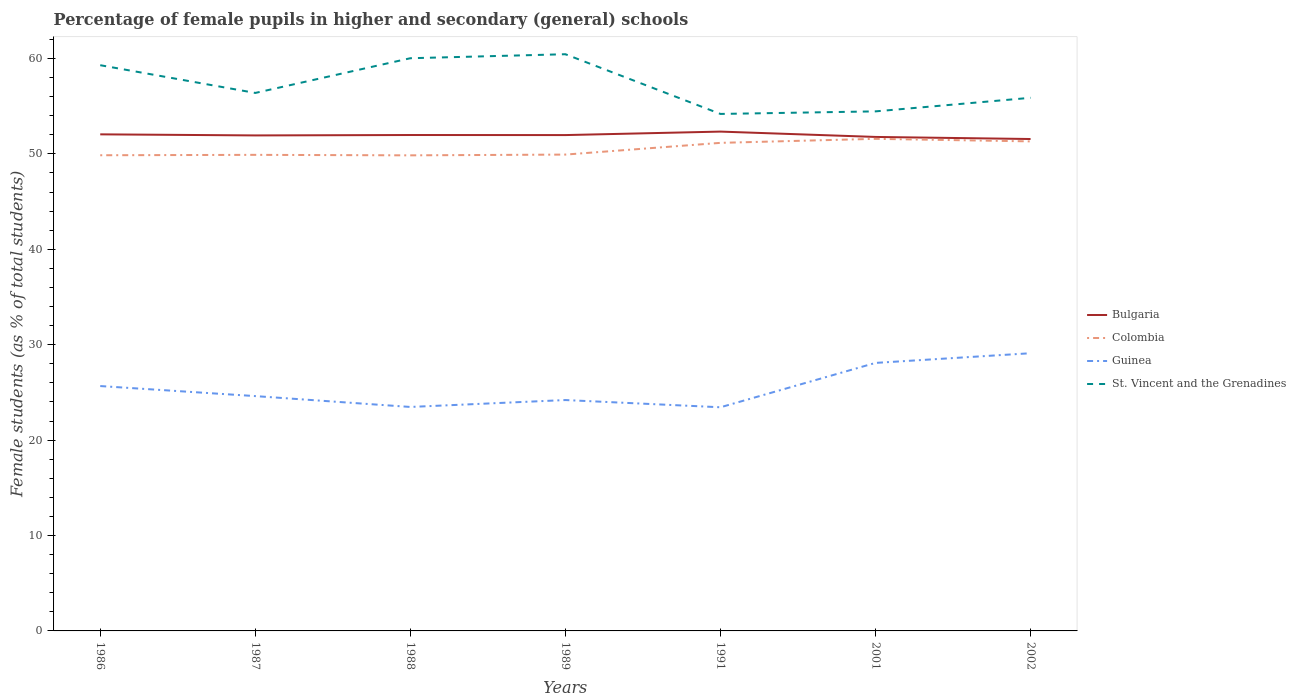Is the number of lines equal to the number of legend labels?
Your response must be concise. Yes. Across all years, what is the maximum percentage of female pupils in higher and secondary schools in St. Vincent and the Grenadines?
Your response must be concise. 54.19. What is the total percentage of female pupils in higher and secondary schools in Colombia in the graph?
Your answer should be very brief. -1.46. What is the difference between the highest and the second highest percentage of female pupils in higher and secondary schools in St. Vincent and the Grenadines?
Give a very brief answer. 6.26. How many lines are there?
Provide a short and direct response. 4. What is the difference between two consecutive major ticks on the Y-axis?
Offer a very short reply. 10. Are the values on the major ticks of Y-axis written in scientific E-notation?
Give a very brief answer. No. Where does the legend appear in the graph?
Your answer should be very brief. Center right. How many legend labels are there?
Provide a succinct answer. 4. How are the legend labels stacked?
Make the answer very short. Vertical. What is the title of the graph?
Keep it short and to the point. Percentage of female pupils in higher and secondary (general) schools. What is the label or title of the X-axis?
Provide a succinct answer. Years. What is the label or title of the Y-axis?
Your response must be concise. Female students (as % of total students). What is the Female students (as % of total students) in Bulgaria in 1986?
Your answer should be very brief. 52.05. What is the Female students (as % of total students) of Colombia in 1986?
Offer a terse response. 49.86. What is the Female students (as % of total students) in Guinea in 1986?
Provide a short and direct response. 25.67. What is the Female students (as % of total students) in St. Vincent and the Grenadines in 1986?
Provide a succinct answer. 59.3. What is the Female students (as % of total students) of Bulgaria in 1987?
Your answer should be very brief. 51.94. What is the Female students (as % of total students) of Colombia in 1987?
Ensure brevity in your answer.  49.9. What is the Female students (as % of total students) of Guinea in 1987?
Provide a succinct answer. 24.61. What is the Female students (as % of total students) of St. Vincent and the Grenadines in 1987?
Provide a short and direct response. 56.39. What is the Female students (as % of total students) in Bulgaria in 1988?
Ensure brevity in your answer.  51.98. What is the Female students (as % of total students) of Colombia in 1988?
Offer a very short reply. 49.85. What is the Female students (as % of total students) of Guinea in 1988?
Make the answer very short. 23.47. What is the Female students (as % of total students) of St. Vincent and the Grenadines in 1988?
Provide a short and direct response. 60.03. What is the Female students (as % of total students) in Bulgaria in 1989?
Make the answer very short. 51.97. What is the Female students (as % of total students) in Colombia in 1989?
Provide a short and direct response. 49.93. What is the Female students (as % of total students) in Guinea in 1989?
Offer a very short reply. 24.2. What is the Female students (as % of total students) of St. Vincent and the Grenadines in 1989?
Provide a succinct answer. 60.45. What is the Female students (as % of total students) of Bulgaria in 1991?
Your answer should be compact. 52.34. What is the Female students (as % of total students) of Colombia in 1991?
Your answer should be very brief. 51.16. What is the Female students (as % of total students) in Guinea in 1991?
Your response must be concise. 23.44. What is the Female students (as % of total students) in St. Vincent and the Grenadines in 1991?
Your answer should be compact. 54.19. What is the Female students (as % of total students) of Bulgaria in 2001?
Make the answer very short. 51.78. What is the Female students (as % of total students) in Colombia in 2001?
Give a very brief answer. 51.58. What is the Female students (as % of total students) in Guinea in 2001?
Make the answer very short. 28.09. What is the Female students (as % of total students) of St. Vincent and the Grenadines in 2001?
Offer a very short reply. 54.46. What is the Female students (as % of total students) of Bulgaria in 2002?
Your answer should be compact. 51.56. What is the Female students (as % of total students) of Colombia in 2002?
Provide a succinct answer. 51.31. What is the Female students (as % of total students) in Guinea in 2002?
Ensure brevity in your answer.  29.11. What is the Female students (as % of total students) in St. Vincent and the Grenadines in 2002?
Ensure brevity in your answer.  55.88. Across all years, what is the maximum Female students (as % of total students) in Bulgaria?
Provide a short and direct response. 52.34. Across all years, what is the maximum Female students (as % of total students) in Colombia?
Offer a terse response. 51.58. Across all years, what is the maximum Female students (as % of total students) in Guinea?
Your answer should be compact. 29.11. Across all years, what is the maximum Female students (as % of total students) in St. Vincent and the Grenadines?
Ensure brevity in your answer.  60.45. Across all years, what is the minimum Female students (as % of total students) in Bulgaria?
Your answer should be very brief. 51.56. Across all years, what is the minimum Female students (as % of total students) in Colombia?
Your response must be concise. 49.85. Across all years, what is the minimum Female students (as % of total students) of Guinea?
Your response must be concise. 23.44. Across all years, what is the minimum Female students (as % of total students) of St. Vincent and the Grenadines?
Offer a very short reply. 54.19. What is the total Female students (as % of total students) in Bulgaria in the graph?
Make the answer very short. 363.61. What is the total Female students (as % of total students) in Colombia in the graph?
Make the answer very short. 353.58. What is the total Female students (as % of total students) in Guinea in the graph?
Keep it short and to the point. 178.59. What is the total Female students (as % of total students) in St. Vincent and the Grenadines in the graph?
Keep it short and to the point. 400.68. What is the difference between the Female students (as % of total students) of Bulgaria in 1986 and that in 1987?
Provide a succinct answer. 0.11. What is the difference between the Female students (as % of total students) in Colombia in 1986 and that in 1987?
Keep it short and to the point. -0.04. What is the difference between the Female students (as % of total students) of Guinea in 1986 and that in 1987?
Provide a succinct answer. 1.05. What is the difference between the Female students (as % of total students) in St. Vincent and the Grenadines in 1986 and that in 1987?
Offer a very short reply. 2.91. What is the difference between the Female students (as % of total students) of Bulgaria in 1986 and that in 1988?
Provide a succinct answer. 0.07. What is the difference between the Female students (as % of total students) in Colombia in 1986 and that in 1988?
Keep it short and to the point. 0.01. What is the difference between the Female students (as % of total students) of Guinea in 1986 and that in 1988?
Offer a terse response. 2.19. What is the difference between the Female students (as % of total students) in St. Vincent and the Grenadines in 1986 and that in 1988?
Your answer should be very brief. -0.73. What is the difference between the Female students (as % of total students) in Bulgaria in 1986 and that in 1989?
Offer a terse response. 0.08. What is the difference between the Female students (as % of total students) in Colombia in 1986 and that in 1989?
Your answer should be very brief. -0.07. What is the difference between the Female students (as % of total students) in Guinea in 1986 and that in 1989?
Ensure brevity in your answer.  1.47. What is the difference between the Female students (as % of total students) in St. Vincent and the Grenadines in 1986 and that in 1989?
Your answer should be compact. -1.15. What is the difference between the Female students (as % of total students) in Bulgaria in 1986 and that in 1991?
Give a very brief answer. -0.29. What is the difference between the Female students (as % of total students) of Colombia in 1986 and that in 1991?
Provide a succinct answer. -1.3. What is the difference between the Female students (as % of total students) of Guinea in 1986 and that in 1991?
Offer a terse response. 2.22. What is the difference between the Female students (as % of total students) of St. Vincent and the Grenadines in 1986 and that in 1991?
Provide a succinct answer. 5.11. What is the difference between the Female students (as % of total students) of Bulgaria in 1986 and that in 2001?
Your answer should be very brief. 0.27. What is the difference between the Female students (as % of total students) in Colombia in 1986 and that in 2001?
Your response must be concise. -1.72. What is the difference between the Female students (as % of total students) in Guinea in 1986 and that in 2001?
Ensure brevity in your answer.  -2.43. What is the difference between the Female students (as % of total students) in St. Vincent and the Grenadines in 1986 and that in 2001?
Your answer should be compact. 4.84. What is the difference between the Female students (as % of total students) of Bulgaria in 1986 and that in 2002?
Keep it short and to the point. 0.49. What is the difference between the Female students (as % of total students) of Colombia in 1986 and that in 2002?
Keep it short and to the point. -1.45. What is the difference between the Female students (as % of total students) in Guinea in 1986 and that in 2002?
Offer a terse response. -3.44. What is the difference between the Female students (as % of total students) in St. Vincent and the Grenadines in 1986 and that in 2002?
Your answer should be compact. 3.42. What is the difference between the Female students (as % of total students) of Bulgaria in 1987 and that in 1988?
Offer a very short reply. -0.04. What is the difference between the Female students (as % of total students) in Colombia in 1987 and that in 1988?
Provide a short and direct response. 0.05. What is the difference between the Female students (as % of total students) of Guinea in 1987 and that in 1988?
Provide a short and direct response. 1.14. What is the difference between the Female students (as % of total students) of St. Vincent and the Grenadines in 1987 and that in 1988?
Provide a short and direct response. -3.64. What is the difference between the Female students (as % of total students) in Bulgaria in 1987 and that in 1989?
Your response must be concise. -0.04. What is the difference between the Female students (as % of total students) of Colombia in 1987 and that in 1989?
Your response must be concise. -0.03. What is the difference between the Female students (as % of total students) of Guinea in 1987 and that in 1989?
Make the answer very short. 0.41. What is the difference between the Female students (as % of total students) of St. Vincent and the Grenadines in 1987 and that in 1989?
Give a very brief answer. -4.06. What is the difference between the Female students (as % of total students) in Bulgaria in 1987 and that in 1991?
Make the answer very short. -0.4. What is the difference between the Female students (as % of total students) of Colombia in 1987 and that in 1991?
Your answer should be very brief. -1.26. What is the difference between the Female students (as % of total students) of Guinea in 1987 and that in 1991?
Provide a short and direct response. 1.17. What is the difference between the Female students (as % of total students) of St. Vincent and the Grenadines in 1987 and that in 1991?
Make the answer very short. 2.2. What is the difference between the Female students (as % of total students) of Bulgaria in 1987 and that in 2001?
Keep it short and to the point. 0.16. What is the difference between the Female students (as % of total students) of Colombia in 1987 and that in 2001?
Offer a terse response. -1.68. What is the difference between the Female students (as % of total students) of Guinea in 1987 and that in 2001?
Your answer should be compact. -3.48. What is the difference between the Female students (as % of total students) of St. Vincent and the Grenadines in 1987 and that in 2001?
Ensure brevity in your answer.  1.93. What is the difference between the Female students (as % of total students) in Bulgaria in 1987 and that in 2002?
Provide a short and direct response. 0.38. What is the difference between the Female students (as % of total students) in Colombia in 1987 and that in 2002?
Offer a very short reply. -1.41. What is the difference between the Female students (as % of total students) in Guinea in 1987 and that in 2002?
Give a very brief answer. -4.49. What is the difference between the Female students (as % of total students) of St. Vincent and the Grenadines in 1987 and that in 2002?
Give a very brief answer. 0.51. What is the difference between the Female students (as % of total students) in Bulgaria in 1988 and that in 1989?
Provide a succinct answer. 0.01. What is the difference between the Female students (as % of total students) of Colombia in 1988 and that in 1989?
Ensure brevity in your answer.  -0.08. What is the difference between the Female students (as % of total students) of Guinea in 1988 and that in 1989?
Your response must be concise. -0.72. What is the difference between the Female students (as % of total students) of St. Vincent and the Grenadines in 1988 and that in 1989?
Ensure brevity in your answer.  -0.42. What is the difference between the Female students (as % of total students) in Bulgaria in 1988 and that in 1991?
Give a very brief answer. -0.36. What is the difference between the Female students (as % of total students) in Colombia in 1988 and that in 1991?
Your answer should be compact. -1.31. What is the difference between the Female students (as % of total students) in Guinea in 1988 and that in 1991?
Keep it short and to the point. 0.03. What is the difference between the Female students (as % of total students) of St. Vincent and the Grenadines in 1988 and that in 1991?
Make the answer very short. 5.84. What is the difference between the Female students (as % of total students) in Bulgaria in 1988 and that in 2001?
Ensure brevity in your answer.  0.2. What is the difference between the Female students (as % of total students) of Colombia in 1988 and that in 2001?
Offer a very short reply. -1.73. What is the difference between the Female students (as % of total students) of Guinea in 1988 and that in 2001?
Make the answer very short. -4.62. What is the difference between the Female students (as % of total students) of St. Vincent and the Grenadines in 1988 and that in 2001?
Ensure brevity in your answer.  5.57. What is the difference between the Female students (as % of total students) in Bulgaria in 1988 and that in 2002?
Your answer should be very brief. 0.42. What is the difference between the Female students (as % of total students) in Colombia in 1988 and that in 2002?
Make the answer very short. -1.46. What is the difference between the Female students (as % of total students) of Guinea in 1988 and that in 2002?
Keep it short and to the point. -5.63. What is the difference between the Female students (as % of total students) of St. Vincent and the Grenadines in 1988 and that in 2002?
Provide a short and direct response. 4.15. What is the difference between the Female students (as % of total students) of Bulgaria in 1989 and that in 1991?
Your answer should be very brief. -0.36. What is the difference between the Female students (as % of total students) in Colombia in 1989 and that in 1991?
Make the answer very short. -1.23. What is the difference between the Female students (as % of total students) in Guinea in 1989 and that in 1991?
Your answer should be compact. 0.76. What is the difference between the Female students (as % of total students) in St. Vincent and the Grenadines in 1989 and that in 1991?
Offer a terse response. 6.26. What is the difference between the Female students (as % of total students) in Bulgaria in 1989 and that in 2001?
Offer a terse response. 0.2. What is the difference between the Female students (as % of total students) in Colombia in 1989 and that in 2001?
Make the answer very short. -1.65. What is the difference between the Female students (as % of total students) of Guinea in 1989 and that in 2001?
Your answer should be very brief. -3.89. What is the difference between the Female students (as % of total students) in St. Vincent and the Grenadines in 1989 and that in 2001?
Keep it short and to the point. 5.99. What is the difference between the Female students (as % of total students) of Bulgaria in 1989 and that in 2002?
Provide a succinct answer. 0.41. What is the difference between the Female students (as % of total students) in Colombia in 1989 and that in 2002?
Your answer should be very brief. -1.38. What is the difference between the Female students (as % of total students) of Guinea in 1989 and that in 2002?
Ensure brevity in your answer.  -4.91. What is the difference between the Female students (as % of total students) of St. Vincent and the Grenadines in 1989 and that in 2002?
Offer a terse response. 4.57. What is the difference between the Female students (as % of total students) of Bulgaria in 1991 and that in 2001?
Offer a terse response. 0.56. What is the difference between the Female students (as % of total students) in Colombia in 1991 and that in 2001?
Make the answer very short. -0.42. What is the difference between the Female students (as % of total students) of Guinea in 1991 and that in 2001?
Give a very brief answer. -4.65. What is the difference between the Female students (as % of total students) of St. Vincent and the Grenadines in 1991 and that in 2001?
Your response must be concise. -0.27. What is the difference between the Female students (as % of total students) of Bulgaria in 1991 and that in 2002?
Provide a succinct answer. 0.78. What is the difference between the Female students (as % of total students) in Colombia in 1991 and that in 2002?
Your answer should be very brief. -0.15. What is the difference between the Female students (as % of total students) in Guinea in 1991 and that in 2002?
Provide a succinct answer. -5.67. What is the difference between the Female students (as % of total students) of St. Vincent and the Grenadines in 1991 and that in 2002?
Your answer should be very brief. -1.69. What is the difference between the Female students (as % of total students) of Bulgaria in 2001 and that in 2002?
Your answer should be compact. 0.22. What is the difference between the Female students (as % of total students) of Colombia in 2001 and that in 2002?
Keep it short and to the point. 0.27. What is the difference between the Female students (as % of total students) in Guinea in 2001 and that in 2002?
Your answer should be very brief. -1.01. What is the difference between the Female students (as % of total students) of St. Vincent and the Grenadines in 2001 and that in 2002?
Provide a short and direct response. -1.42. What is the difference between the Female students (as % of total students) of Bulgaria in 1986 and the Female students (as % of total students) of Colombia in 1987?
Offer a very short reply. 2.15. What is the difference between the Female students (as % of total students) in Bulgaria in 1986 and the Female students (as % of total students) in Guinea in 1987?
Ensure brevity in your answer.  27.44. What is the difference between the Female students (as % of total students) in Bulgaria in 1986 and the Female students (as % of total students) in St. Vincent and the Grenadines in 1987?
Provide a succinct answer. -4.34. What is the difference between the Female students (as % of total students) of Colombia in 1986 and the Female students (as % of total students) of Guinea in 1987?
Provide a short and direct response. 25.24. What is the difference between the Female students (as % of total students) of Colombia in 1986 and the Female students (as % of total students) of St. Vincent and the Grenadines in 1987?
Your answer should be compact. -6.53. What is the difference between the Female students (as % of total students) in Guinea in 1986 and the Female students (as % of total students) in St. Vincent and the Grenadines in 1987?
Your answer should be very brief. -30.72. What is the difference between the Female students (as % of total students) of Bulgaria in 1986 and the Female students (as % of total students) of Colombia in 1988?
Your answer should be compact. 2.2. What is the difference between the Female students (as % of total students) in Bulgaria in 1986 and the Female students (as % of total students) in Guinea in 1988?
Ensure brevity in your answer.  28.57. What is the difference between the Female students (as % of total students) of Bulgaria in 1986 and the Female students (as % of total students) of St. Vincent and the Grenadines in 1988?
Keep it short and to the point. -7.98. What is the difference between the Female students (as % of total students) of Colombia in 1986 and the Female students (as % of total students) of Guinea in 1988?
Offer a very short reply. 26.38. What is the difference between the Female students (as % of total students) in Colombia in 1986 and the Female students (as % of total students) in St. Vincent and the Grenadines in 1988?
Your answer should be compact. -10.17. What is the difference between the Female students (as % of total students) in Guinea in 1986 and the Female students (as % of total students) in St. Vincent and the Grenadines in 1988?
Your answer should be compact. -34.36. What is the difference between the Female students (as % of total students) in Bulgaria in 1986 and the Female students (as % of total students) in Colombia in 1989?
Make the answer very short. 2.12. What is the difference between the Female students (as % of total students) of Bulgaria in 1986 and the Female students (as % of total students) of Guinea in 1989?
Offer a very short reply. 27.85. What is the difference between the Female students (as % of total students) of Bulgaria in 1986 and the Female students (as % of total students) of St. Vincent and the Grenadines in 1989?
Your response must be concise. -8.4. What is the difference between the Female students (as % of total students) of Colombia in 1986 and the Female students (as % of total students) of Guinea in 1989?
Keep it short and to the point. 25.66. What is the difference between the Female students (as % of total students) of Colombia in 1986 and the Female students (as % of total students) of St. Vincent and the Grenadines in 1989?
Offer a very short reply. -10.59. What is the difference between the Female students (as % of total students) of Guinea in 1986 and the Female students (as % of total students) of St. Vincent and the Grenadines in 1989?
Give a very brief answer. -34.78. What is the difference between the Female students (as % of total students) of Bulgaria in 1986 and the Female students (as % of total students) of Colombia in 1991?
Provide a short and direct response. 0.89. What is the difference between the Female students (as % of total students) in Bulgaria in 1986 and the Female students (as % of total students) in Guinea in 1991?
Your answer should be very brief. 28.61. What is the difference between the Female students (as % of total students) of Bulgaria in 1986 and the Female students (as % of total students) of St. Vincent and the Grenadines in 1991?
Make the answer very short. -2.14. What is the difference between the Female students (as % of total students) of Colombia in 1986 and the Female students (as % of total students) of Guinea in 1991?
Offer a terse response. 26.42. What is the difference between the Female students (as % of total students) of Colombia in 1986 and the Female students (as % of total students) of St. Vincent and the Grenadines in 1991?
Give a very brief answer. -4.33. What is the difference between the Female students (as % of total students) in Guinea in 1986 and the Female students (as % of total students) in St. Vincent and the Grenadines in 1991?
Keep it short and to the point. -28.52. What is the difference between the Female students (as % of total students) in Bulgaria in 1986 and the Female students (as % of total students) in Colombia in 2001?
Make the answer very short. 0.47. What is the difference between the Female students (as % of total students) in Bulgaria in 1986 and the Female students (as % of total students) in Guinea in 2001?
Your answer should be compact. 23.96. What is the difference between the Female students (as % of total students) of Bulgaria in 1986 and the Female students (as % of total students) of St. Vincent and the Grenadines in 2001?
Your response must be concise. -2.41. What is the difference between the Female students (as % of total students) of Colombia in 1986 and the Female students (as % of total students) of Guinea in 2001?
Your answer should be compact. 21.76. What is the difference between the Female students (as % of total students) of Colombia in 1986 and the Female students (as % of total students) of St. Vincent and the Grenadines in 2001?
Offer a very short reply. -4.6. What is the difference between the Female students (as % of total students) of Guinea in 1986 and the Female students (as % of total students) of St. Vincent and the Grenadines in 2001?
Keep it short and to the point. -28.79. What is the difference between the Female students (as % of total students) of Bulgaria in 1986 and the Female students (as % of total students) of Colombia in 2002?
Ensure brevity in your answer.  0.74. What is the difference between the Female students (as % of total students) in Bulgaria in 1986 and the Female students (as % of total students) in Guinea in 2002?
Keep it short and to the point. 22.94. What is the difference between the Female students (as % of total students) in Bulgaria in 1986 and the Female students (as % of total students) in St. Vincent and the Grenadines in 2002?
Ensure brevity in your answer.  -3.83. What is the difference between the Female students (as % of total students) of Colombia in 1986 and the Female students (as % of total students) of Guinea in 2002?
Provide a succinct answer. 20.75. What is the difference between the Female students (as % of total students) of Colombia in 1986 and the Female students (as % of total students) of St. Vincent and the Grenadines in 2002?
Make the answer very short. -6.02. What is the difference between the Female students (as % of total students) of Guinea in 1986 and the Female students (as % of total students) of St. Vincent and the Grenadines in 2002?
Provide a short and direct response. -30.21. What is the difference between the Female students (as % of total students) of Bulgaria in 1987 and the Female students (as % of total students) of Colombia in 1988?
Your response must be concise. 2.09. What is the difference between the Female students (as % of total students) of Bulgaria in 1987 and the Female students (as % of total students) of Guinea in 1988?
Give a very brief answer. 28.46. What is the difference between the Female students (as % of total students) of Bulgaria in 1987 and the Female students (as % of total students) of St. Vincent and the Grenadines in 1988?
Offer a very short reply. -8.09. What is the difference between the Female students (as % of total students) of Colombia in 1987 and the Female students (as % of total students) of Guinea in 1988?
Offer a terse response. 26.42. What is the difference between the Female students (as % of total students) of Colombia in 1987 and the Female students (as % of total students) of St. Vincent and the Grenadines in 1988?
Provide a short and direct response. -10.13. What is the difference between the Female students (as % of total students) of Guinea in 1987 and the Female students (as % of total students) of St. Vincent and the Grenadines in 1988?
Your response must be concise. -35.41. What is the difference between the Female students (as % of total students) in Bulgaria in 1987 and the Female students (as % of total students) in Colombia in 1989?
Make the answer very short. 2.01. What is the difference between the Female students (as % of total students) in Bulgaria in 1987 and the Female students (as % of total students) in Guinea in 1989?
Provide a succinct answer. 27.74. What is the difference between the Female students (as % of total students) of Bulgaria in 1987 and the Female students (as % of total students) of St. Vincent and the Grenadines in 1989?
Offer a terse response. -8.51. What is the difference between the Female students (as % of total students) of Colombia in 1987 and the Female students (as % of total students) of Guinea in 1989?
Make the answer very short. 25.7. What is the difference between the Female students (as % of total students) in Colombia in 1987 and the Female students (as % of total students) in St. Vincent and the Grenadines in 1989?
Provide a succinct answer. -10.55. What is the difference between the Female students (as % of total students) in Guinea in 1987 and the Female students (as % of total students) in St. Vincent and the Grenadines in 1989?
Make the answer very short. -35.83. What is the difference between the Female students (as % of total students) in Bulgaria in 1987 and the Female students (as % of total students) in Colombia in 1991?
Offer a very short reply. 0.78. What is the difference between the Female students (as % of total students) of Bulgaria in 1987 and the Female students (as % of total students) of Guinea in 1991?
Give a very brief answer. 28.49. What is the difference between the Female students (as % of total students) in Bulgaria in 1987 and the Female students (as % of total students) in St. Vincent and the Grenadines in 1991?
Make the answer very short. -2.25. What is the difference between the Female students (as % of total students) in Colombia in 1987 and the Female students (as % of total students) in Guinea in 1991?
Keep it short and to the point. 26.46. What is the difference between the Female students (as % of total students) of Colombia in 1987 and the Female students (as % of total students) of St. Vincent and the Grenadines in 1991?
Make the answer very short. -4.29. What is the difference between the Female students (as % of total students) in Guinea in 1987 and the Female students (as % of total students) in St. Vincent and the Grenadines in 1991?
Your answer should be very brief. -29.57. What is the difference between the Female students (as % of total students) of Bulgaria in 1987 and the Female students (as % of total students) of Colombia in 2001?
Your answer should be very brief. 0.36. What is the difference between the Female students (as % of total students) of Bulgaria in 1987 and the Female students (as % of total students) of Guinea in 2001?
Give a very brief answer. 23.84. What is the difference between the Female students (as % of total students) of Bulgaria in 1987 and the Female students (as % of total students) of St. Vincent and the Grenadines in 2001?
Provide a succinct answer. -2.52. What is the difference between the Female students (as % of total students) in Colombia in 1987 and the Female students (as % of total students) in Guinea in 2001?
Ensure brevity in your answer.  21.81. What is the difference between the Female students (as % of total students) of Colombia in 1987 and the Female students (as % of total students) of St. Vincent and the Grenadines in 2001?
Provide a short and direct response. -4.56. What is the difference between the Female students (as % of total students) of Guinea in 1987 and the Female students (as % of total students) of St. Vincent and the Grenadines in 2001?
Give a very brief answer. -29.84. What is the difference between the Female students (as % of total students) of Bulgaria in 1987 and the Female students (as % of total students) of Colombia in 2002?
Ensure brevity in your answer.  0.63. What is the difference between the Female students (as % of total students) in Bulgaria in 1987 and the Female students (as % of total students) in Guinea in 2002?
Offer a terse response. 22.83. What is the difference between the Female students (as % of total students) in Bulgaria in 1987 and the Female students (as % of total students) in St. Vincent and the Grenadines in 2002?
Your response must be concise. -3.94. What is the difference between the Female students (as % of total students) of Colombia in 1987 and the Female students (as % of total students) of Guinea in 2002?
Ensure brevity in your answer.  20.79. What is the difference between the Female students (as % of total students) of Colombia in 1987 and the Female students (as % of total students) of St. Vincent and the Grenadines in 2002?
Ensure brevity in your answer.  -5.98. What is the difference between the Female students (as % of total students) of Guinea in 1987 and the Female students (as % of total students) of St. Vincent and the Grenadines in 2002?
Keep it short and to the point. -31.27. What is the difference between the Female students (as % of total students) in Bulgaria in 1988 and the Female students (as % of total students) in Colombia in 1989?
Your answer should be very brief. 2.05. What is the difference between the Female students (as % of total students) of Bulgaria in 1988 and the Female students (as % of total students) of Guinea in 1989?
Your answer should be very brief. 27.78. What is the difference between the Female students (as % of total students) in Bulgaria in 1988 and the Female students (as % of total students) in St. Vincent and the Grenadines in 1989?
Make the answer very short. -8.47. What is the difference between the Female students (as % of total students) of Colombia in 1988 and the Female students (as % of total students) of Guinea in 1989?
Offer a terse response. 25.65. What is the difference between the Female students (as % of total students) of Colombia in 1988 and the Female students (as % of total students) of St. Vincent and the Grenadines in 1989?
Your answer should be very brief. -10.6. What is the difference between the Female students (as % of total students) in Guinea in 1988 and the Female students (as % of total students) in St. Vincent and the Grenadines in 1989?
Offer a very short reply. -36.97. What is the difference between the Female students (as % of total students) in Bulgaria in 1988 and the Female students (as % of total students) in Colombia in 1991?
Provide a succinct answer. 0.82. What is the difference between the Female students (as % of total students) of Bulgaria in 1988 and the Female students (as % of total students) of Guinea in 1991?
Ensure brevity in your answer.  28.54. What is the difference between the Female students (as % of total students) of Bulgaria in 1988 and the Female students (as % of total students) of St. Vincent and the Grenadines in 1991?
Your answer should be very brief. -2.21. What is the difference between the Female students (as % of total students) of Colombia in 1988 and the Female students (as % of total students) of Guinea in 1991?
Offer a terse response. 26.41. What is the difference between the Female students (as % of total students) of Colombia in 1988 and the Female students (as % of total students) of St. Vincent and the Grenadines in 1991?
Ensure brevity in your answer.  -4.34. What is the difference between the Female students (as % of total students) in Guinea in 1988 and the Female students (as % of total students) in St. Vincent and the Grenadines in 1991?
Your response must be concise. -30.71. What is the difference between the Female students (as % of total students) in Bulgaria in 1988 and the Female students (as % of total students) in Colombia in 2001?
Your response must be concise. 0.4. What is the difference between the Female students (as % of total students) of Bulgaria in 1988 and the Female students (as % of total students) of Guinea in 2001?
Keep it short and to the point. 23.89. What is the difference between the Female students (as % of total students) of Bulgaria in 1988 and the Female students (as % of total students) of St. Vincent and the Grenadines in 2001?
Make the answer very short. -2.48. What is the difference between the Female students (as % of total students) of Colombia in 1988 and the Female students (as % of total students) of Guinea in 2001?
Your answer should be compact. 21.76. What is the difference between the Female students (as % of total students) of Colombia in 1988 and the Female students (as % of total students) of St. Vincent and the Grenadines in 2001?
Give a very brief answer. -4.61. What is the difference between the Female students (as % of total students) in Guinea in 1988 and the Female students (as % of total students) in St. Vincent and the Grenadines in 2001?
Your response must be concise. -30.98. What is the difference between the Female students (as % of total students) in Bulgaria in 1988 and the Female students (as % of total students) in Colombia in 2002?
Your answer should be very brief. 0.67. What is the difference between the Female students (as % of total students) in Bulgaria in 1988 and the Female students (as % of total students) in Guinea in 2002?
Your answer should be very brief. 22.87. What is the difference between the Female students (as % of total students) in Colombia in 1988 and the Female students (as % of total students) in Guinea in 2002?
Your response must be concise. 20.74. What is the difference between the Female students (as % of total students) in Colombia in 1988 and the Female students (as % of total students) in St. Vincent and the Grenadines in 2002?
Provide a short and direct response. -6.03. What is the difference between the Female students (as % of total students) of Guinea in 1988 and the Female students (as % of total students) of St. Vincent and the Grenadines in 2002?
Offer a terse response. -32.4. What is the difference between the Female students (as % of total students) of Bulgaria in 1989 and the Female students (as % of total students) of Colombia in 1991?
Keep it short and to the point. 0.82. What is the difference between the Female students (as % of total students) in Bulgaria in 1989 and the Female students (as % of total students) in Guinea in 1991?
Ensure brevity in your answer.  28.53. What is the difference between the Female students (as % of total students) of Bulgaria in 1989 and the Female students (as % of total students) of St. Vincent and the Grenadines in 1991?
Provide a succinct answer. -2.21. What is the difference between the Female students (as % of total students) in Colombia in 1989 and the Female students (as % of total students) in Guinea in 1991?
Provide a succinct answer. 26.49. What is the difference between the Female students (as % of total students) in Colombia in 1989 and the Female students (as % of total students) in St. Vincent and the Grenadines in 1991?
Provide a short and direct response. -4.26. What is the difference between the Female students (as % of total students) of Guinea in 1989 and the Female students (as % of total students) of St. Vincent and the Grenadines in 1991?
Offer a terse response. -29.99. What is the difference between the Female students (as % of total students) in Bulgaria in 1989 and the Female students (as % of total students) in Colombia in 2001?
Offer a terse response. 0.39. What is the difference between the Female students (as % of total students) of Bulgaria in 1989 and the Female students (as % of total students) of Guinea in 2001?
Keep it short and to the point. 23.88. What is the difference between the Female students (as % of total students) of Bulgaria in 1989 and the Female students (as % of total students) of St. Vincent and the Grenadines in 2001?
Provide a short and direct response. -2.48. What is the difference between the Female students (as % of total students) of Colombia in 1989 and the Female students (as % of total students) of Guinea in 2001?
Your answer should be compact. 21.83. What is the difference between the Female students (as % of total students) in Colombia in 1989 and the Female students (as % of total students) in St. Vincent and the Grenadines in 2001?
Provide a succinct answer. -4.53. What is the difference between the Female students (as % of total students) of Guinea in 1989 and the Female students (as % of total students) of St. Vincent and the Grenadines in 2001?
Provide a short and direct response. -30.26. What is the difference between the Female students (as % of total students) in Bulgaria in 1989 and the Female students (as % of total students) in Colombia in 2002?
Your response must be concise. 0.66. What is the difference between the Female students (as % of total students) of Bulgaria in 1989 and the Female students (as % of total students) of Guinea in 2002?
Offer a terse response. 22.87. What is the difference between the Female students (as % of total students) of Bulgaria in 1989 and the Female students (as % of total students) of St. Vincent and the Grenadines in 2002?
Offer a terse response. -3.91. What is the difference between the Female students (as % of total students) in Colombia in 1989 and the Female students (as % of total students) in Guinea in 2002?
Your answer should be very brief. 20.82. What is the difference between the Female students (as % of total students) of Colombia in 1989 and the Female students (as % of total students) of St. Vincent and the Grenadines in 2002?
Offer a terse response. -5.95. What is the difference between the Female students (as % of total students) in Guinea in 1989 and the Female students (as % of total students) in St. Vincent and the Grenadines in 2002?
Give a very brief answer. -31.68. What is the difference between the Female students (as % of total students) of Bulgaria in 1991 and the Female students (as % of total students) of Colombia in 2001?
Make the answer very short. 0.76. What is the difference between the Female students (as % of total students) in Bulgaria in 1991 and the Female students (as % of total students) in Guinea in 2001?
Your answer should be compact. 24.24. What is the difference between the Female students (as % of total students) of Bulgaria in 1991 and the Female students (as % of total students) of St. Vincent and the Grenadines in 2001?
Your answer should be compact. -2.12. What is the difference between the Female students (as % of total students) in Colombia in 1991 and the Female students (as % of total students) in Guinea in 2001?
Offer a terse response. 23.06. What is the difference between the Female students (as % of total students) in Colombia in 1991 and the Female students (as % of total students) in St. Vincent and the Grenadines in 2001?
Your answer should be compact. -3.3. What is the difference between the Female students (as % of total students) of Guinea in 1991 and the Female students (as % of total students) of St. Vincent and the Grenadines in 2001?
Your answer should be compact. -31.01. What is the difference between the Female students (as % of total students) in Bulgaria in 1991 and the Female students (as % of total students) in Colombia in 2002?
Keep it short and to the point. 1.03. What is the difference between the Female students (as % of total students) in Bulgaria in 1991 and the Female students (as % of total students) in Guinea in 2002?
Give a very brief answer. 23.23. What is the difference between the Female students (as % of total students) of Bulgaria in 1991 and the Female students (as % of total students) of St. Vincent and the Grenadines in 2002?
Provide a succinct answer. -3.54. What is the difference between the Female students (as % of total students) in Colombia in 1991 and the Female students (as % of total students) in Guinea in 2002?
Your answer should be compact. 22.05. What is the difference between the Female students (as % of total students) in Colombia in 1991 and the Female students (as % of total students) in St. Vincent and the Grenadines in 2002?
Offer a very short reply. -4.72. What is the difference between the Female students (as % of total students) in Guinea in 1991 and the Female students (as % of total students) in St. Vincent and the Grenadines in 2002?
Keep it short and to the point. -32.44. What is the difference between the Female students (as % of total students) of Bulgaria in 2001 and the Female students (as % of total students) of Colombia in 2002?
Offer a terse response. 0.47. What is the difference between the Female students (as % of total students) in Bulgaria in 2001 and the Female students (as % of total students) in Guinea in 2002?
Give a very brief answer. 22.67. What is the difference between the Female students (as % of total students) of Bulgaria in 2001 and the Female students (as % of total students) of St. Vincent and the Grenadines in 2002?
Ensure brevity in your answer.  -4.1. What is the difference between the Female students (as % of total students) in Colombia in 2001 and the Female students (as % of total students) in Guinea in 2002?
Your answer should be compact. 22.47. What is the difference between the Female students (as % of total students) in Colombia in 2001 and the Female students (as % of total students) in St. Vincent and the Grenadines in 2002?
Make the answer very short. -4.3. What is the difference between the Female students (as % of total students) in Guinea in 2001 and the Female students (as % of total students) in St. Vincent and the Grenadines in 2002?
Offer a terse response. -27.79. What is the average Female students (as % of total students) in Bulgaria per year?
Offer a very short reply. 51.94. What is the average Female students (as % of total students) in Colombia per year?
Ensure brevity in your answer.  50.51. What is the average Female students (as % of total students) in Guinea per year?
Ensure brevity in your answer.  25.51. What is the average Female students (as % of total students) of St. Vincent and the Grenadines per year?
Provide a succinct answer. 57.24. In the year 1986, what is the difference between the Female students (as % of total students) of Bulgaria and Female students (as % of total students) of Colombia?
Provide a short and direct response. 2.19. In the year 1986, what is the difference between the Female students (as % of total students) in Bulgaria and Female students (as % of total students) in Guinea?
Provide a succinct answer. 26.38. In the year 1986, what is the difference between the Female students (as % of total students) of Bulgaria and Female students (as % of total students) of St. Vincent and the Grenadines?
Give a very brief answer. -7.25. In the year 1986, what is the difference between the Female students (as % of total students) of Colombia and Female students (as % of total students) of Guinea?
Offer a very short reply. 24.19. In the year 1986, what is the difference between the Female students (as % of total students) of Colombia and Female students (as % of total students) of St. Vincent and the Grenadines?
Provide a short and direct response. -9.44. In the year 1986, what is the difference between the Female students (as % of total students) in Guinea and Female students (as % of total students) in St. Vincent and the Grenadines?
Provide a succinct answer. -33.63. In the year 1987, what is the difference between the Female students (as % of total students) of Bulgaria and Female students (as % of total students) of Colombia?
Your answer should be very brief. 2.04. In the year 1987, what is the difference between the Female students (as % of total students) of Bulgaria and Female students (as % of total students) of Guinea?
Offer a terse response. 27.32. In the year 1987, what is the difference between the Female students (as % of total students) in Bulgaria and Female students (as % of total students) in St. Vincent and the Grenadines?
Offer a very short reply. -4.45. In the year 1987, what is the difference between the Female students (as % of total students) of Colombia and Female students (as % of total students) of Guinea?
Provide a succinct answer. 25.29. In the year 1987, what is the difference between the Female students (as % of total students) of Colombia and Female students (as % of total students) of St. Vincent and the Grenadines?
Your answer should be very brief. -6.49. In the year 1987, what is the difference between the Female students (as % of total students) in Guinea and Female students (as % of total students) in St. Vincent and the Grenadines?
Your answer should be compact. -31.78. In the year 1988, what is the difference between the Female students (as % of total students) of Bulgaria and Female students (as % of total students) of Colombia?
Your response must be concise. 2.13. In the year 1988, what is the difference between the Female students (as % of total students) in Bulgaria and Female students (as % of total students) in Guinea?
Make the answer very short. 28.5. In the year 1988, what is the difference between the Female students (as % of total students) in Bulgaria and Female students (as % of total students) in St. Vincent and the Grenadines?
Provide a short and direct response. -8.05. In the year 1988, what is the difference between the Female students (as % of total students) in Colombia and Female students (as % of total students) in Guinea?
Offer a very short reply. 26.37. In the year 1988, what is the difference between the Female students (as % of total students) in Colombia and Female students (as % of total students) in St. Vincent and the Grenadines?
Ensure brevity in your answer.  -10.18. In the year 1988, what is the difference between the Female students (as % of total students) in Guinea and Female students (as % of total students) in St. Vincent and the Grenadines?
Keep it short and to the point. -36.55. In the year 1989, what is the difference between the Female students (as % of total students) in Bulgaria and Female students (as % of total students) in Colombia?
Your answer should be compact. 2.04. In the year 1989, what is the difference between the Female students (as % of total students) of Bulgaria and Female students (as % of total students) of Guinea?
Your answer should be very brief. 27.77. In the year 1989, what is the difference between the Female students (as % of total students) of Bulgaria and Female students (as % of total students) of St. Vincent and the Grenadines?
Provide a short and direct response. -8.47. In the year 1989, what is the difference between the Female students (as % of total students) in Colombia and Female students (as % of total students) in Guinea?
Provide a succinct answer. 25.73. In the year 1989, what is the difference between the Female students (as % of total students) in Colombia and Female students (as % of total students) in St. Vincent and the Grenadines?
Ensure brevity in your answer.  -10.52. In the year 1989, what is the difference between the Female students (as % of total students) of Guinea and Female students (as % of total students) of St. Vincent and the Grenadines?
Your answer should be very brief. -36.25. In the year 1991, what is the difference between the Female students (as % of total students) in Bulgaria and Female students (as % of total students) in Colombia?
Your response must be concise. 1.18. In the year 1991, what is the difference between the Female students (as % of total students) in Bulgaria and Female students (as % of total students) in Guinea?
Ensure brevity in your answer.  28.9. In the year 1991, what is the difference between the Female students (as % of total students) in Bulgaria and Female students (as % of total students) in St. Vincent and the Grenadines?
Your answer should be compact. -1.85. In the year 1991, what is the difference between the Female students (as % of total students) of Colombia and Female students (as % of total students) of Guinea?
Offer a very short reply. 27.71. In the year 1991, what is the difference between the Female students (as % of total students) of Colombia and Female students (as % of total students) of St. Vincent and the Grenadines?
Provide a succinct answer. -3.03. In the year 1991, what is the difference between the Female students (as % of total students) of Guinea and Female students (as % of total students) of St. Vincent and the Grenadines?
Your answer should be compact. -30.75. In the year 2001, what is the difference between the Female students (as % of total students) of Bulgaria and Female students (as % of total students) of Colombia?
Offer a terse response. 0.2. In the year 2001, what is the difference between the Female students (as % of total students) of Bulgaria and Female students (as % of total students) of Guinea?
Provide a succinct answer. 23.68. In the year 2001, what is the difference between the Female students (as % of total students) of Bulgaria and Female students (as % of total students) of St. Vincent and the Grenadines?
Provide a short and direct response. -2.68. In the year 2001, what is the difference between the Female students (as % of total students) of Colombia and Female students (as % of total students) of Guinea?
Your answer should be very brief. 23.49. In the year 2001, what is the difference between the Female students (as % of total students) in Colombia and Female students (as % of total students) in St. Vincent and the Grenadines?
Give a very brief answer. -2.88. In the year 2001, what is the difference between the Female students (as % of total students) of Guinea and Female students (as % of total students) of St. Vincent and the Grenadines?
Offer a terse response. -26.36. In the year 2002, what is the difference between the Female students (as % of total students) of Bulgaria and Female students (as % of total students) of Colombia?
Provide a succinct answer. 0.25. In the year 2002, what is the difference between the Female students (as % of total students) in Bulgaria and Female students (as % of total students) in Guinea?
Give a very brief answer. 22.45. In the year 2002, what is the difference between the Female students (as % of total students) of Bulgaria and Female students (as % of total students) of St. Vincent and the Grenadines?
Keep it short and to the point. -4.32. In the year 2002, what is the difference between the Female students (as % of total students) of Colombia and Female students (as % of total students) of Guinea?
Provide a succinct answer. 22.2. In the year 2002, what is the difference between the Female students (as % of total students) in Colombia and Female students (as % of total students) in St. Vincent and the Grenadines?
Your answer should be very brief. -4.57. In the year 2002, what is the difference between the Female students (as % of total students) of Guinea and Female students (as % of total students) of St. Vincent and the Grenadines?
Your response must be concise. -26.77. What is the ratio of the Female students (as % of total students) of Guinea in 1986 to that in 1987?
Offer a terse response. 1.04. What is the ratio of the Female students (as % of total students) of St. Vincent and the Grenadines in 1986 to that in 1987?
Offer a very short reply. 1.05. What is the ratio of the Female students (as % of total students) in Colombia in 1986 to that in 1988?
Your response must be concise. 1. What is the ratio of the Female students (as % of total students) of Guinea in 1986 to that in 1988?
Provide a short and direct response. 1.09. What is the ratio of the Female students (as % of total students) in Bulgaria in 1986 to that in 1989?
Provide a short and direct response. 1. What is the ratio of the Female students (as % of total students) in Guinea in 1986 to that in 1989?
Keep it short and to the point. 1.06. What is the ratio of the Female students (as % of total students) in St. Vincent and the Grenadines in 1986 to that in 1989?
Your response must be concise. 0.98. What is the ratio of the Female students (as % of total students) in Colombia in 1986 to that in 1991?
Provide a succinct answer. 0.97. What is the ratio of the Female students (as % of total students) in Guinea in 1986 to that in 1991?
Provide a succinct answer. 1.09. What is the ratio of the Female students (as % of total students) of St. Vincent and the Grenadines in 1986 to that in 1991?
Give a very brief answer. 1.09. What is the ratio of the Female students (as % of total students) in Colombia in 1986 to that in 2001?
Provide a short and direct response. 0.97. What is the ratio of the Female students (as % of total students) of Guinea in 1986 to that in 2001?
Give a very brief answer. 0.91. What is the ratio of the Female students (as % of total students) of St. Vincent and the Grenadines in 1986 to that in 2001?
Ensure brevity in your answer.  1.09. What is the ratio of the Female students (as % of total students) of Bulgaria in 1986 to that in 2002?
Offer a very short reply. 1.01. What is the ratio of the Female students (as % of total students) in Colombia in 1986 to that in 2002?
Make the answer very short. 0.97. What is the ratio of the Female students (as % of total students) of Guinea in 1986 to that in 2002?
Provide a short and direct response. 0.88. What is the ratio of the Female students (as % of total students) in St. Vincent and the Grenadines in 1986 to that in 2002?
Ensure brevity in your answer.  1.06. What is the ratio of the Female students (as % of total students) of Bulgaria in 1987 to that in 1988?
Offer a very short reply. 1. What is the ratio of the Female students (as % of total students) of Colombia in 1987 to that in 1988?
Make the answer very short. 1. What is the ratio of the Female students (as % of total students) of Guinea in 1987 to that in 1988?
Keep it short and to the point. 1.05. What is the ratio of the Female students (as % of total students) in St. Vincent and the Grenadines in 1987 to that in 1988?
Offer a very short reply. 0.94. What is the ratio of the Female students (as % of total students) of Bulgaria in 1987 to that in 1989?
Provide a short and direct response. 1. What is the ratio of the Female students (as % of total students) in Guinea in 1987 to that in 1989?
Keep it short and to the point. 1.02. What is the ratio of the Female students (as % of total students) in St. Vincent and the Grenadines in 1987 to that in 1989?
Your response must be concise. 0.93. What is the ratio of the Female students (as % of total students) of Bulgaria in 1987 to that in 1991?
Your response must be concise. 0.99. What is the ratio of the Female students (as % of total students) in Colombia in 1987 to that in 1991?
Provide a succinct answer. 0.98. What is the ratio of the Female students (as % of total students) of St. Vincent and the Grenadines in 1987 to that in 1991?
Your answer should be compact. 1.04. What is the ratio of the Female students (as % of total students) in Bulgaria in 1987 to that in 2001?
Make the answer very short. 1. What is the ratio of the Female students (as % of total students) of Colombia in 1987 to that in 2001?
Offer a very short reply. 0.97. What is the ratio of the Female students (as % of total students) of Guinea in 1987 to that in 2001?
Your response must be concise. 0.88. What is the ratio of the Female students (as % of total students) of St. Vincent and the Grenadines in 1987 to that in 2001?
Offer a very short reply. 1.04. What is the ratio of the Female students (as % of total students) of Bulgaria in 1987 to that in 2002?
Keep it short and to the point. 1.01. What is the ratio of the Female students (as % of total students) in Colombia in 1987 to that in 2002?
Offer a terse response. 0.97. What is the ratio of the Female students (as % of total students) of Guinea in 1987 to that in 2002?
Ensure brevity in your answer.  0.85. What is the ratio of the Female students (as % of total students) of St. Vincent and the Grenadines in 1987 to that in 2002?
Provide a short and direct response. 1.01. What is the ratio of the Female students (as % of total students) in Bulgaria in 1988 to that in 1989?
Your response must be concise. 1. What is the ratio of the Female students (as % of total students) in Guinea in 1988 to that in 1989?
Provide a succinct answer. 0.97. What is the ratio of the Female students (as % of total students) in St. Vincent and the Grenadines in 1988 to that in 1989?
Provide a succinct answer. 0.99. What is the ratio of the Female students (as % of total students) of Colombia in 1988 to that in 1991?
Ensure brevity in your answer.  0.97. What is the ratio of the Female students (as % of total students) of Guinea in 1988 to that in 1991?
Your answer should be very brief. 1. What is the ratio of the Female students (as % of total students) in St. Vincent and the Grenadines in 1988 to that in 1991?
Ensure brevity in your answer.  1.11. What is the ratio of the Female students (as % of total students) of Bulgaria in 1988 to that in 2001?
Your response must be concise. 1. What is the ratio of the Female students (as % of total students) in Colombia in 1988 to that in 2001?
Your answer should be compact. 0.97. What is the ratio of the Female students (as % of total students) of Guinea in 1988 to that in 2001?
Your answer should be compact. 0.84. What is the ratio of the Female students (as % of total students) of St. Vincent and the Grenadines in 1988 to that in 2001?
Keep it short and to the point. 1.1. What is the ratio of the Female students (as % of total students) in Colombia in 1988 to that in 2002?
Offer a very short reply. 0.97. What is the ratio of the Female students (as % of total students) of Guinea in 1988 to that in 2002?
Offer a terse response. 0.81. What is the ratio of the Female students (as % of total students) of St. Vincent and the Grenadines in 1988 to that in 2002?
Give a very brief answer. 1.07. What is the ratio of the Female students (as % of total students) of Bulgaria in 1989 to that in 1991?
Provide a succinct answer. 0.99. What is the ratio of the Female students (as % of total students) in Colombia in 1989 to that in 1991?
Your answer should be very brief. 0.98. What is the ratio of the Female students (as % of total students) in Guinea in 1989 to that in 1991?
Offer a terse response. 1.03. What is the ratio of the Female students (as % of total students) in St. Vincent and the Grenadines in 1989 to that in 1991?
Ensure brevity in your answer.  1.12. What is the ratio of the Female students (as % of total students) of Guinea in 1989 to that in 2001?
Keep it short and to the point. 0.86. What is the ratio of the Female students (as % of total students) in St. Vincent and the Grenadines in 1989 to that in 2001?
Ensure brevity in your answer.  1.11. What is the ratio of the Female students (as % of total students) of Bulgaria in 1989 to that in 2002?
Offer a terse response. 1.01. What is the ratio of the Female students (as % of total students) in Guinea in 1989 to that in 2002?
Provide a short and direct response. 0.83. What is the ratio of the Female students (as % of total students) of St. Vincent and the Grenadines in 1989 to that in 2002?
Your response must be concise. 1.08. What is the ratio of the Female students (as % of total students) in Bulgaria in 1991 to that in 2001?
Your answer should be compact. 1.01. What is the ratio of the Female students (as % of total students) of Guinea in 1991 to that in 2001?
Ensure brevity in your answer.  0.83. What is the ratio of the Female students (as % of total students) in St. Vincent and the Grenadines in 1991 to that in 2001?
Give a very brief answer. 1. What is the ratio of the Female students (as % of total students) of Bulgaria in 1991 to that in 2002?
Provide a short and direct response. 1.02. What is the ratio of the Female students (as % of total students) of Colombia in 1991 to that in 2002?
Make the answer very short. 1. What is the ratio of the Female students (as % of total students) of Guinea in 1991 to that in 2002?
Make the answer very short. 0.81. What is the ratio of the Female students (as % of total students) of St. Vincent and the Grenadines in 1991 to that in 2002?
Ensure brevity in your answer.  0.97. What is the ratio of the Female students (as % of total students) in Bulgaria in 2001 to that in 2002?
Provide a succinct answer. 1. What is the ratio of the Female students (as % of total students) of Guinea in 2001 to that in 2002?
Keep it short and to the point. 0.97. What is the ratio of the Female students (as % of total students) of St. Vincent and the Grenadines in 2001 to that in 2002?
Offer a terse response. 0.97. What is the difference between the highest and the second highest Female students (as % of total students) of Bulgaria?
Your answer should be very brief. 0.29. What is the difference between the highest and the second highest Female students (as % of total students) of Colombia?
Offer a very short reply. 0.27. What is the difference between the highest and the second highest Female students (as % of total students) of Guinea?
Your answer should be compact. 1.01. What is the difference between the highest and the second highest Female students (as % of total students) of St. Vincent and the Grenadines?
Your response must be concise. 0.42. What is the difference between the highest and the lowest Female students (as % of total students) in Bulgaria?
Your answer should be compact. 0.78. What is the difference between the highest and the lowest Female students (as % of total students) of Colombia?
Your response must be concise. 1.73. What is the difference between the highest and the lowest Female students (as % of total students) of Guinea?
Give a very brief answer. 5.67. What is the difference between the highest and the lowest Female students (as % of total students) of St. Vincent and the Grenadines?
Provide a short and direct response. 6.26. 